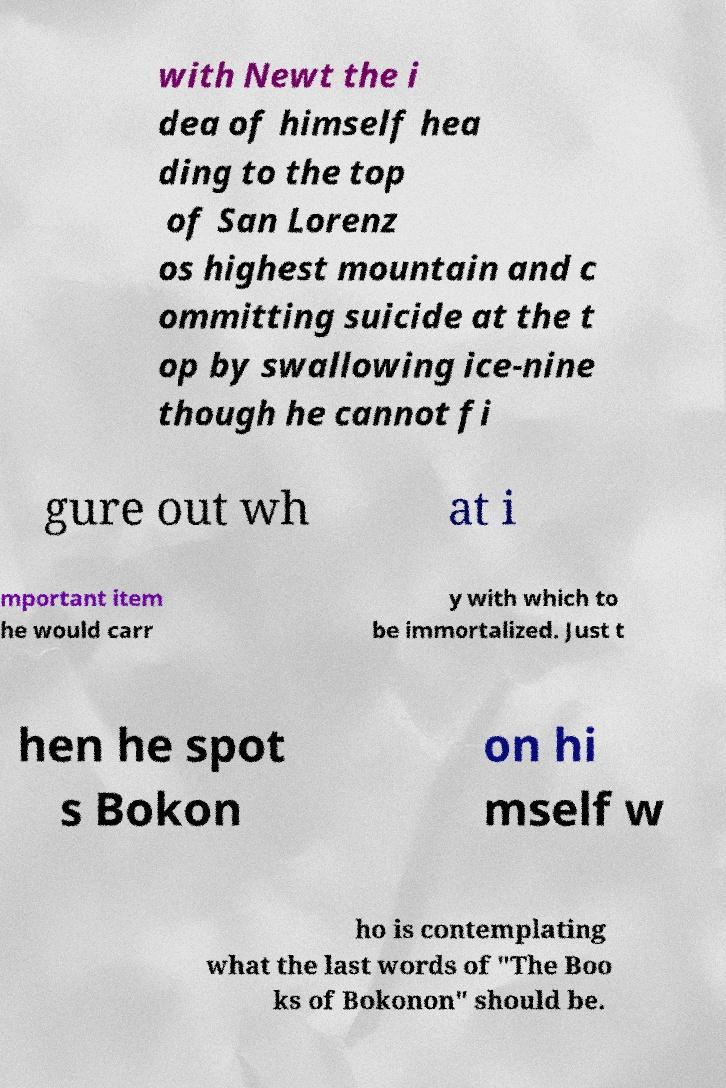For documentation purposes, I need the text within this image transcribed. Could you provide that? with Newt the i dea of himself hea ding to the top of San Lorenz os highest mountain and c ommitting suicide at the t op by swallowing ice-nine though he cannot fi gure out wh at i mportant item he would carr y with which to be immortalized. Just t hen he spot s Bokon on hi mself w ho is contemplating what the last words of "The Boo ks of Bokonon" should be. 